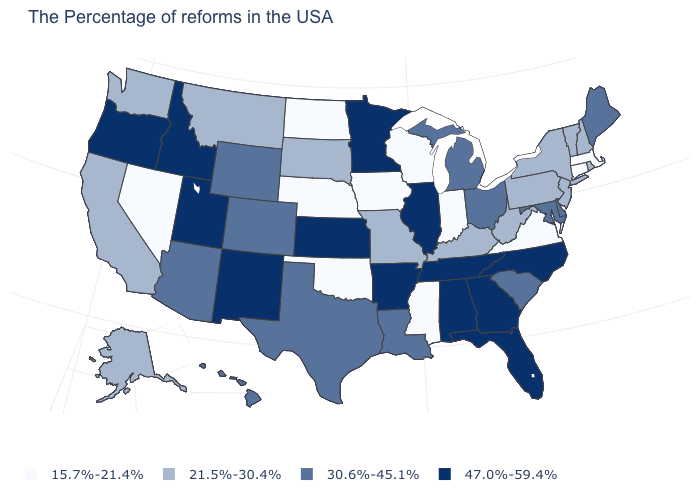Which states hav the highest value in the Northeast?
Be succinct. Maine. What is the value of Massachusetts?
Give a very brief answer. 15.7%-21.4%. What is the value of New York?
Be succinct. 21.5%-30.4%. What is the value of South Carolina?
Concise answer only. 30.6%-45.1%. What is the value of Alabama?
Give a very brief answer. 47.0%-59.4%. What is the value of Louisiana?
Write a very short answer. 30.6%-45.1%. What is the highest value in the USA?
Write a very short answer. 47.0%-59.4%. Which states have the lowest value in the USA?
Give a very brief answer. Massachusetts, Connecticut, Virginia, Indiana, Wisconsin, Mississippi, Iowa, Nebraska, Oklahoma, North Dakota, Nevada. Does Rhode Island have the lowest value in the Northeast?
Give a very brief answer. No. What is the value of Connecticut?
Quick response, please. 15.7%-21.4%. Which states have the lowest value in the USA?
Answer briefly. Massachusetts, Connecticut, Virginia, Indiana, Wisconsin, Mississippi, Iowa, Nebraska, Oklahoma, North Dakota, Nevada. What is the value of Alaska?
Give a very brief answer. 21.5%-30.4%. Name the states that have a value in the range 47.0%-59.4%?
Short answer required. North Carolina, Florida, Georgia, Alabama, Tennessee, Illinois, Arkansas, Minnesota, Kansas, New Mexico, Utah, Idaho, Oregon. Among the states that border New Jersey , does Pennsylvania have the lowest value?
Write a very short answer. Yes. Which states have the lowest value in the West?
Answer briefly. Nevada. 